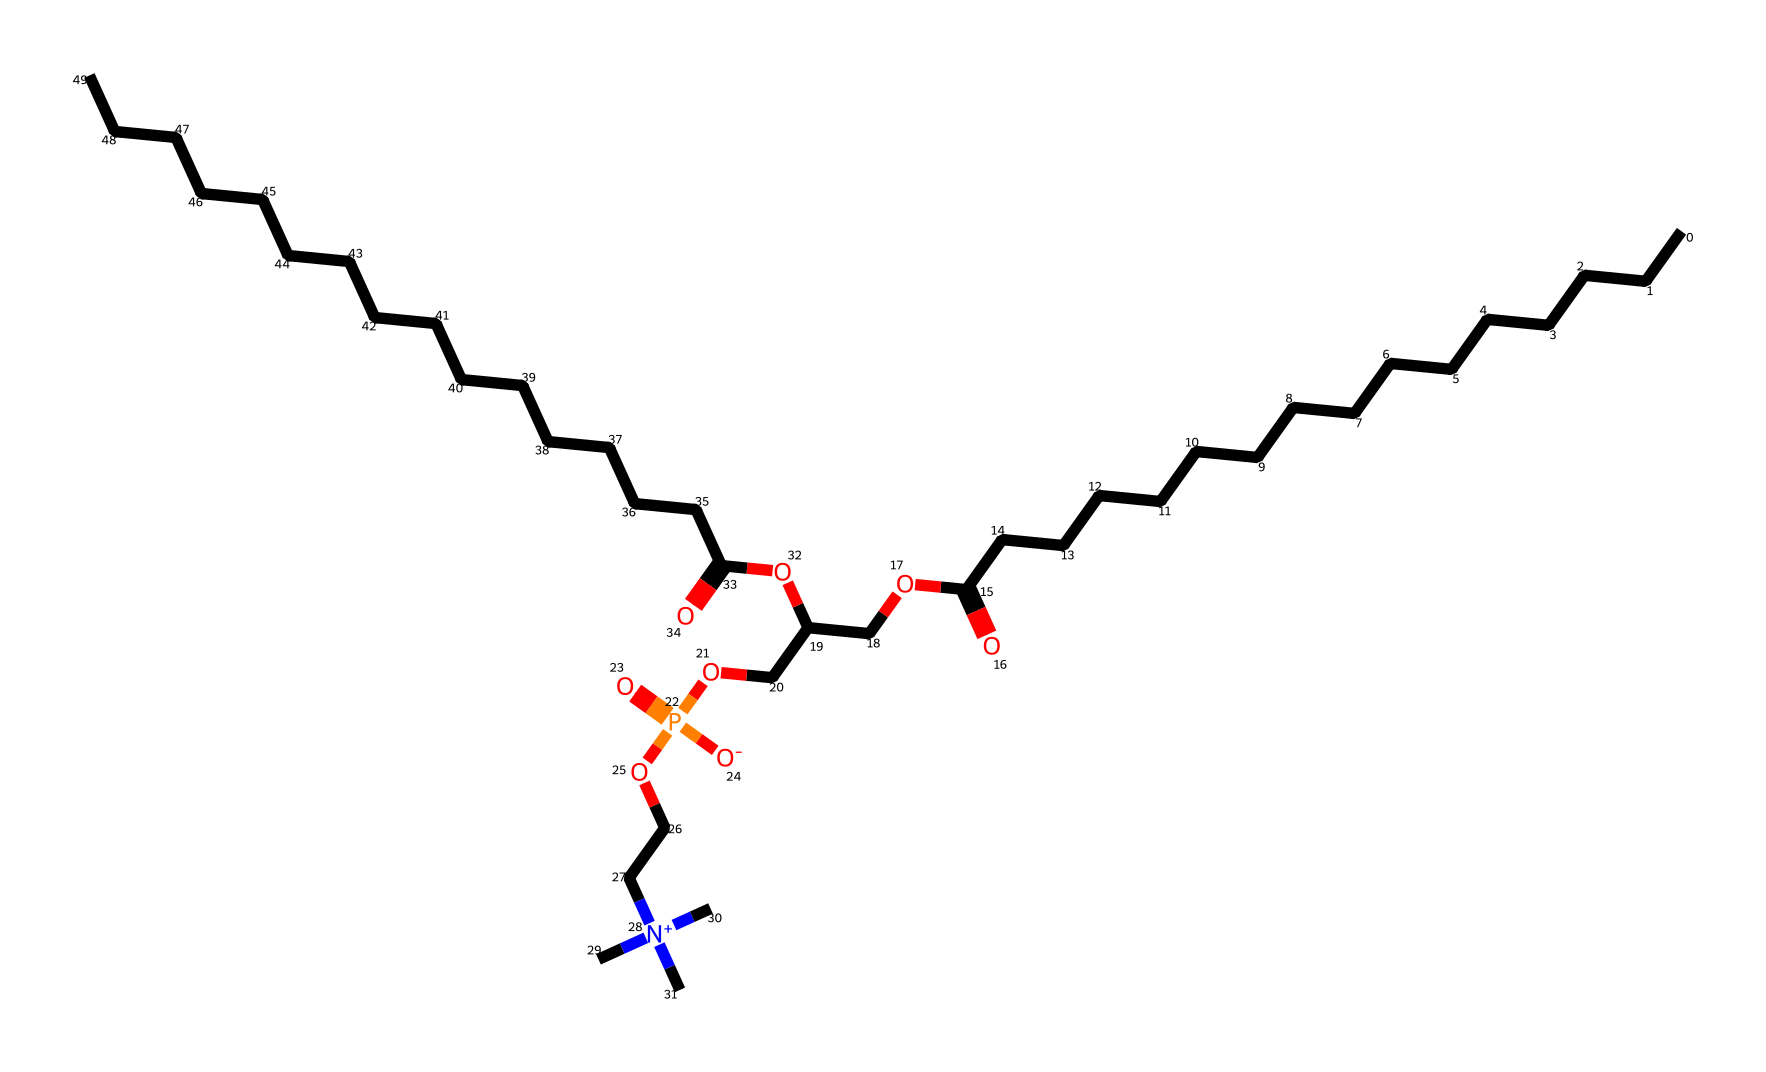What is the primary functional group present in this phospholipid? The phospholipid contains a phosphate group (P=O) as its primary functional group, recognizable in the structure where oxygen is double-bonded to phosphorus and connected to other atoms.
Answer: phosphate group How many carbon atoms are in the main fatty acid chain of this molecule? By counting the "C" symbols in the long hydrocarbon chain portion of the SMILES representation, there are 16 carbon atoms participating in the fatty acid chain.
Answer: 16 What type of chemical bond connects the carbon atoms in the hydrocarbon chain? The carbon atoms in the hydrocarbon chain are connected by single covalent bonds, as indicated by the lack of double bonds in the segment of the chain without unsaturation.
Answer: single bonds What is the overall charge of this phospholipid molecule? The presence of the phosphate group with its negative charge indicates that the molecule has an overall charge, specifically, it is ionized to have a net negative charge.
Answer: negative Which component of this phospholipid makes it amphipathic? The presence of both hydrophilic (the phosphate group) and hydrophobic (the long carbon chains) regions in the molecule allows it to be amphipathic, meaning it has both water-attracting and water-repelling characteristics.
Answer: amphipathic What kind of lipid is this molecule classified as? This molecule falls under the category of a phospholipid, which is characterized by having a glycerol backbone, two fatty acids, and a phosphate group.
Answer: phospholipid How many ester linkages does this phospholipid have? By analyzing the structure, there are two ester linkages formed between the fatty acids and the glycerol component of the molecule.
Answer: two 